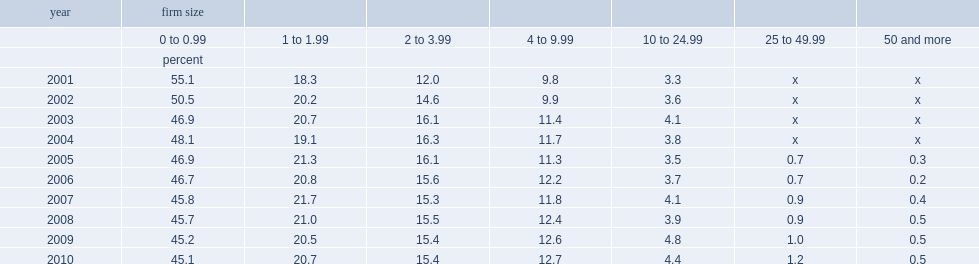What the percent of businesses of fewer than 2 employees after 10 years in canada? 65.8. What the percent of businesses of 2 to 20 employees after 10 years in canada? 28.1. What the percent of businesses of more than 10 employees after 10 years in canada? 6.1. 